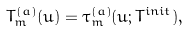Convert formula to latex. <formula><loc_0><loc_0><loc_500><loc_500>& T ^ { ( a ) } _ { m } ( u ) = \tau ^ { ( a ) } _ { m } ( u ; T ^ { i n i t } ) ,</formula> 